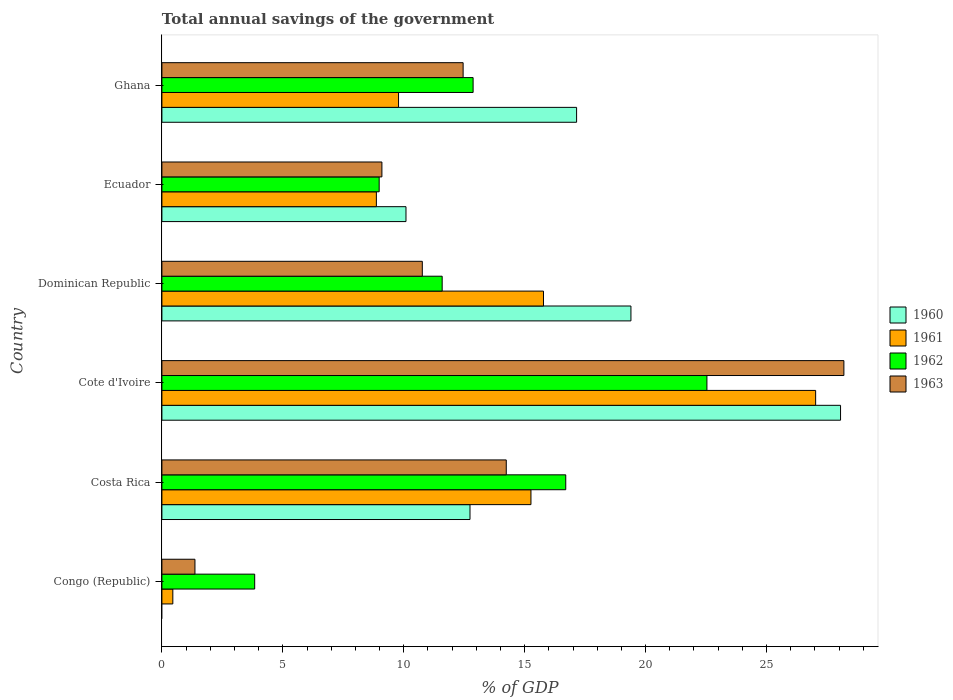How many bars are there on the 1st tick from the top?
Your response must be concise. 4. What is the label of the 4th group of bars from the top?
Your answer should be compact. Cote d'Ivoire. In how many cases, is the number of bars for a given country not equal to the number of legend labels?
Your answer should be compact. 1. What is the total annual savings of the government in 1962 in Ghana?
Give a very brief answer. 12.87. Across all countries, what is the maximum total annual savings of the government in 1962?
Make the answer very short. 22.54. In which country was the total annual savings of the government in 1960 maximum?
Give a very brief answer. Cote d'Ivoire. What is the total total annual savings of the government in 1960 in the graph?
Your response must be concise. 87.43. What is the difference between the total annual savings of the government in 1961 in Congo (Republic) and that in Ecuador?
Provide a succinct answer. -8.42. What is the difference between the total annual savings of the government in 1963 in Ghana and the total annual savings of the government in 1962 in Costa Rica?
Make the answer very short. -4.24. What is the average total annual savings of the government in 1960 per country?
Offer a very short reply. 14.57. What is the difference between the total annual savings of the government in 1963 and total annual savings of the government in 1960 in Costa Rica?
Your answer should be very brief. 1.5. In how many countries, is the total annual savings of the government in 1960 greater than 28 %?
Offer a very short reply. 1. What is the ratio of the total annual savings of the government in 1960 in Dominican Republic to that in Ghana?
Provide a succinct answer. 1.13. Is the total annual savings of the government in 1963 in Congo (Republic) less than that in Cote d'Ivoire?
Ensure brevity in your answer.  Yes. What is the difference between the highest and the second highest total annual savings of the government in 1963?
Your answer should be very brief. 13.96. What is the difference between the highest and the lowest total annual savings of the government in 1962?
Keep it short and to the point. 18.7. Is the sum of the total annual savings of the government in 1961 in Congo (Republic) and Costa Rica greater than the maximum total annual savings of the government in 1962 across all countries?
Ensure brevity in your answer.  No. Is it the case that in every country, the sum of the total annual savings of the government in 1962 and total annual savings of the government in 1960 is greater than the sum of total annual savings of the government in 1961 and total annual savings of the government in 1963?
Ensure brevity in your answer.  No. How many countries are there in the graph?
Keep it short and to the point. 6. Does the graph contain any zero values?
Your answer should be very brief. Yes. Does the graph contain grids?
Your response must be concise. No. How many legend labels are there?
Provide a succinct answer. 4. How are the legend labels stacked?
Make the answer very short. Vertical. What is the title of the graph?
Make the answer very short. Total annual savings of the government. Does "1967" appear as one of the legend labels in the graph?
Give a very brief answer. No. What is the label or title of the X-axis?
Keep it short and to the point. % of GDP. What is the label or title of the Y-axis?
Offer a terse response. Country. What is the % of GDP in 1961 in Congo (Republic)?
Your answer should be very brief. 0.45. What is the % of GDP in 1962 in Congo (Republic)?
Ensure brevity in your answer.  3.84. What is the % of GDP of 1963 in Congo (Republic)?
Your response must be concise. 1.37. What is the % of GDP of 1960 in Costa Rica?
Give a very brief answer. 12.74. What is the % of GDP in 1961 in Costa Rica?
Make the answer very short. 15.26. What is the % of GDP in 1962 in Costa Rica?
Your response must be concise. 16.7. What is the % of GDP of 1963 in Costa Rica?
Your answer should be compact. 14.24. What is the % of GDP in 1960 in Cote d'Ivoire?
Provide a succinct answer. 28.06. What is the % of GDP in 1961 in Cote d'Ivoire?
Your response must be concise. 27.03. What is the % of GDP in 1962 in Cote d'Ivoire?
Give a very brief answer. 22.54. What is the % of GDP in 1963 in Cote d'Ivoire?
Keep it short and to the point. 28.2. What is the % of GDP in 1960 in Dominican Republic?
Your answer should be compact. 19.39. What is the % of GDP in 1961 in Dominican Republic?
Make the answer very short. 15.78. What is the % of GDP in 1962 in Dominican Republic?
Keep it short and to the point. 11.59. What is the % of GDP in 1963 in Dominican Republic?
Provide a short and direct response. 10.77. What is the % of GDP of 1960 in Ecuador?
Your response must be concise. 10.09. What is the % of GDP in 1961 in Ecuador?
Your answer should be compact. 8.87. What is the % of GDP of 1962 in Ecuador?
Give a very brief answer. 8.98. What is the % of GDP in 1963 in Ecuador?
Provide a succinct answer. 9.1. What is the % of GDP in 1960 in Ghana?
Ensure brevity in your answer.  17.15. What is the % of GDP in 1961 in Ghana?
Your answer should be very brief. 9.78. What is the % of GDP in 1962 in Ghana?
Your answer should be compact. 12.87. What is the % of GDP in 1963 in Ghana?
Ensure brevity in your answer.  12.45. Across all countries, what is the maximum % of GDP in 1960?
Make the answer very short. 28.06. Across all countries, what is the maximum % of GDP of 1961?
Provide a short and direct response. 27.03. Across all countries, what is the maximum % of GDP of 1962?
Offer a terse response. 22.54. Across all countries, what is the maximum % of GDP in 1963?
Offer a very short reply. 28.2. Across all countries, what is the minimum % of GDP of 1961?
Give a very brief answer. 0.45. Across all countries, what is the minimum % of GDP of 1962?
Your answer should be compact. 3.84. Across all countries, what is the minimum % of GDP of 1963?
Your answer should be compact. 1.37. What is the total % of GDP of 1960 in the graph?
Keep it short and to the point. 87.43. What is the total % of GDP of 1961 in the graph?
Your answer should be very brief. 77.17. What is the total % of GDP in 1962 in the graph?
Provide a succinct answer. 76.51. What is the total % of GDP of 1963 in the graph?
Keep it short and to the point. 76.12. What is the difference between the % of GDP of 1961 in Congo (Republic) and that in Costa Rica?
Ensure brevity in your answer.  -14.81. What is the difference between the % of GDP of 1962 in Congo (Republic) and that in Costa Rica?
Provide a short and direct response. -12.86. What is the difference between the % of GDP in 1963 in Congo (Republic) and that in Costa Rica?
Offer a very short reply. -12.87. What is the difference between the % of GDP in 1961 in Congo (Republic) and that in Cote d'Ivoire?
Your answer should be compact. -26.58. What is the difference between the % of GDP in 1962 in Congo (Republic) and that in Cote d'Ivoire?
Keep it short and to the point. -18.7. What is the difference between the % of GDP of 1963 in Congo (Republic) and that in Cote d'Ivoire?
Your answer should be compact. -26.83. What is the difference between the % of GDP in 1961 in Congo (Republic) and that in Dominican Republic?
Ensure brevity in your answer.  -15.33. What is the difference between the % of GDP in 1962 in Congo (Republic) and that in Dominican Republic?
Ensure brevity in your answer.  -7.75. What is the difference between the % of GDP in 1963 in Congo (Republic) and that in Dominican Republic?
Your answer should be very brief. -9.4. What is the difference between the % of GDP in 1961 in Congo (Republic) and that in Ecuador?
Give a very brief answer. -8.42. What is the difference between the % of GDP in 1962 in Congo (Republic) and that in Ecuador?
Keep it short and to the point. -5.15. What is the difference between the % of GDP of 1963 in Congo (Republic) and that in Ecuador?
Give a very brief answer. -7.73. What is the difference between the % of GDP of 1961 in Congo (Republic) and that in Ghana?
Offer a very short reply. -9.33. What is the difference between the % of GDP in 1962 in Congo (Republic) and that in Ghana?
Give a very brief answer. -9.03. What is the difference between the % of GDP of 1963 in Congo (Republic) and that in Ghana?
Offer a very short reply. -11.09. What is the difference between the % of GDP in 1960 in Costa Rica and that in Cote d'Ivoire?
Provide a short and direct response. -15.32. What is the difference between the % of GDP of 1961 in Costa Rica and that in Cote d'Ivoire?
Ensure brevity in your answer.  -11.77. What is the difference between the % of GDP in 1962 in Costa Rica and that in Cote d'Ivoire?
Your response must be concise. -5.84. What is the difference between the % of GDP of 1963 in Costa Rica and that in Cote d'Ivoire?
Provide a succinct answer. -13.96. What is the difference between the % of GDP of 1960 in Costa Rica and that in Dominican Republic?
Ensure brevity in your answer.  -6.65. What is the difference between the % of GDP in 1961 in Costa Rica and that in Dominican Republic?
Keep it short and to the point. -0.52. What is the difference between the % of GDP in 1962 in Costa Rica and that in Dominican Republic?
Offer a terse response. 5.11. What is the difference between the % of GDP of 1963 in Costa Rica and that in Dominican Republic?
Offer a terse response. 3.47. What is the difference between the % of GDP of 1960 in Costa Rica and that in Ecuador?
Give a very brief answer. 2.65. What is the difference between the % of GDP of 1961 in Costa Rica and that in Ecuador?
Ensure brevity in your answer.  6.39. What is the difference between the % of GDP of 1962 in Costa Rica and that in Ecuador?
Provide a succinct answer. 7.71. What is the difference between the % of GDP in 1963 in Costa Rica and that in Ecuador?
Make the answer very short. 5.14. What is the difference between the % of GDP of 1960 in Costa Rica and that in Ghana?
Offer a very short reply. -4.41. What is the difference between the % of GDP of 1961 in Costa Rica and that in Ghana?
Provide a succinct answer. 5.47. What is the difference between the % of GDP of 1962 in Costa Rica and that in Ghana?
Offer a very short reply. 3.83. What is the difference between the % of GDP of 1963 in Costa Rica and that in Ghana?
Offer a terse response. 1.78. What is the difference between the % of GDP of 1960 in Cote d'Ivoire and that in Dominican Republic?
Give a very brief answer. 8.67. What is the difference between the % of GDP of 1961 in Cote d'Ivoire and that in Dominican Republic?
Offer a terse response. 11.25. What is the difference between the % of GDP in 1962 in Cote d'Ivoire and that in Dominican Republic?
Offer a very short reply. 10.95. What is the difference between the % of GDP in 1963 in Cote d'Ivoire and that in Dominican Republic?
Provide a short and direct response. 17.43. What is the difference between the % of GDP in 1960 in Cote d'Ivoire and that in Ecuador?
Your answer should be very brief. 17.97. What is the difference between the % of GDP of 1961 in Cote d'Ivoire and that in Ecuador?
Your response must be concise. 18.16. What is the difference between the % of GDP in 1962 in Cote d'Ivoire and that in Ecuador?
Ensure brevity in your answer.  13.55. What is the difference between the % of GDP of 1963 in Cote d'Ivoire and that in Ecuador?
Keep it short and to the point. 19.1. What is the difference between the % of GDP in 1960 in Cote d'Ivoire and that in Ghana?
Your answer should be compact. 10.91. What is the difference between the % of GDP of 1961 in Cote d'Ivoire and that in Ghana?
Give a very brief answer. 17.25. What is the difference between the % of GDP in 1962 in Cote d'Ivoire and that in Ghana?
Offer a very short reply. 9.67. What is the difference between the % of GDP in 1963 in Cote d'Ivoire and that in Ghana?
Provide a short and direct response. 15.74. What is the difference between the % of GDP in 1960 in Dominican Republic and that in Ecuador?
Your response must be concise. 9.3. What is the difference between the % of GDP of 1961 in Dominican Republic and that in Ecuador?
Your answer should be very brief. 6.91. What is the difference between the % of GDP in 1962 in Dominican Republic and that in Ecuador?
Provide a short and direct response. 2.61. What is the difference between the % of GDP in 1963 in Dominican Republic and that in Ecuador?
Provide a succinct answer. 1.67. What is the difference between the % of GDP in 1960 in Dominican Republic and that in Ghana?
Offer a terse response. 2.25. What is the difference between the % of GDP in 1961 in Dominican Republic and that in Ghana?
Give a very brief answer. 5.99. What is the difference between the % of GDP in 1962 in Dominican Republic and that in Ghana?
Ensure brevity in your answer.  -1.28. What is the difference between the % of GDP in 1963 in Dominican Republic and that in Ghana?
Offer a terse response. -1.69. What is the difference between the % of GDP in 1960 in Ecuador and that in Ghana?
Make the answer very short. -7.05. What is the difference between the % of GDP in 1961 in Ecuador and that in Ghana?
Keep it short and to the point. -0.92. What is the difference between the % of GDP in 1962 in Ecuador and that in Ghana?
Offer a terse response. -3.88. What is the difference between the % of GDP in 1963 in Ecuador and that in Ghana?
Ensure brevity in your answer.  -3.36. What is the difference between the % of GDP of 1961 in Congo (Republic) and the % of GDP of 1962 in Costa Rica?
Offer a terse response. -16.25. What is the difference between the % of GDP of 1961 in Congo (Republic) and the % of GDP of 1963 in Costa Rica?
Your response must be concise. -13.79. What is the difference between the % of GDP of 1962 in Congo (Republic) and the % of GDP of 1963 in Costa Rica?
Provide a succinct answer. -10.4. What is the difference between the % of GDP in 1961 in Congo (Republic) and the % of GDP in 1962 in Cote d'Ivoire?
Keep it short and to the point. -22.08. What is the difference between the % of GDP of 1961 in Congo (Republic) and the % of GDP of 1963 in Cote d'Ivoire?
Make the answer very short. -27.75. What is the difference between the % of GDP of 1962 in Congo (Republic) and the % of GDP of 1963 in Cote d'Ivoire?
Your answer should be very brief. -24.36. What is the difference between the % of GDP of 1961 in Congo (Republic) and the % of GDP of 1962 in Dominican Republic?
Offer a very short reply. -11.14. What is the difference between the % of GDP in 1961 in Congo (Republic) and the % of GDP in 1963 in Dominican Republic?
Your answer should be very brief. -10.32. What is the difference between the % of GDP of 1962 in Congo (Republic) and the % of GDP of 1963 in Dominican Republic?
Ensure brevity in your answer.  -6.93. What is the difference between the % of GDP of 1961 in Congo (Republic) and the % of GDP of 1962 in Ecuador?
Provide a short and direct response. -8.53. What is the difference between the % of GDP in 1961 in Congo (Republic) and the % of GDP in 1963 in Ecuador?
Make the answer very short. -8.64. What is the difference between the % of GDP of 1962 in Congo (Republic) and the % of GDP of 1963 in Ecuador?
Provide a succinct answer. -5.26. What is the difference between the % of GDP in 1961 in Congo (Republic) and the % of GDP in 1962 in Ghana?
Provide a succinct answer. -12.42. What is the difference between the % of GDP of 1961 in Congo (Republic) and the % of GDP of 1963 in Ghana?
Your answer should be very brief. -12. What is the difference between the % of GDP in 1962 in Congo (Republic) and the % of GDP in 1963 in Ghana?
Provide a succinct answer. -8.62. What is the difference between the % of GDP of 1960 in Costa Rica and the % of GDP of 1961 in Cote d'Ivoire?
Provide a succinct answer. -14.29. What is the difference between the % of GDP of 1960 in Costa Rica and the % of GDP of 1962 in Cote d'Ivoire?
Your response must be concise. -9.8. What is the difference between the % of GDP of 1960 in Costa Rica and the % of GDP of 1963 in Cote d'Ivoire?
Offer a terse response. -15.46. What is the difference between the % of GDP of 1961 in Costa Rica and the % of GDP of 1962 in Cote d'Ivoire?
Your answer should be compact. -7.28. What is the difference between the % of GDP in 1961 in Costa Rica and the % of GDP in 1963 in Cote d'Ivoire?
Offer a terse response. -12.94. What is the difference between the % of GDP in 1962 in Costa Rica and the % of GDP in 1963 in Cote d'Ivoire?
Your response must be concise. -11.5. What is the difference between the % of GDP of 1960 in Costa Rica and the % of GDP of 1961 in Dominican Republic?
Your answer should be compact. -3.04. What is the difference between the % of GDP in 1960 in Costa Rica and the % of GDP in 1962 in Dominican Republic?
Offer a terse response. 1.15. What is the difference between the % of GDP in 1960 in Costa Rica and the % of GDP in 1963 in Dominican Republic?
Ensure brevity in your answer.  1.97. What is the difference between the % of GDP of 1961 in Costa Rica and the % of GDP of 1962 in Dominican Republic?
Keep it short and to the point. 3.67. What is the difference between the % of GDP of 1961 in Costa Rica and the % of GDP of 1963 in Dominican Republic?
Offer a terse response. 4.49. What is the difference between the % of GDP in 1962 in Costa Rica and the % of GDP in 1963 in Dominican Republic?
Your answer should be compact. 5.93. What is the difference between the % of GDP of 1960 in Costa Rica and the % of GDP of 1961 in Ecuador?
Your answer should be very brief. 3.87. What is the difference between the % of GDP in 1960 in Costa Rica and the % of GDP in 1962 in Ecuador?
Keep it short and to the point. 3.76. What is the difference between the % of GDP in 1960 in Costa Rica and the % of GDP in 1963 in Ecuador?
Offer a terse response. 3.64. What is the difference between the % of GDP of 1961 in Costa Rica and the % of GDP of 1962 in Ecuador?
Your answer should be very brief. 6.28. What is the difference between the % of GDP in 1961 in Costa Rica and the % of GDP in 1963 in Ecuador?
Make the answer very short. 6.16. What is the difference between the % of GDP in 1962 in Costa Rica and the % of GDP in 1963 in Ecuador?
Your response must be concise. 7.6. What is the difference between the % of GDP of 1960 in Costa Rica and the % of GDP of 1961 in Ghana?
Your answer should be very brief. 2.95. What is the difference between the % of GDP of 1960 in Costa Rica and the % of GDP of 1962 in Ghana?
Offer a terse response. -0.13. What is the difference between the % of GDP of 1960 in Costa Rica and the % of GDP of 1963 in Ghana?
Provide a short and direct response. 0.28. What is the difference between the % of GDP in 1961 in Costa Rica and the % of GDP in 1962 in Ghana?
Provide a short and direct response. 2.39. What is the difference between the % of GDP of 1961 in Costa Rica and the % of GDP of 1963 in Ghana?
Your response must be concise. 2.81. What is the difference between the % of GDP of 1962 in Costa Rica and the % of GDP of 1963 in Ghana?
Provide a succinct answer. 4.24. What is the difference between the % of GDP in 1960 in Cote d'Ivoire and the % of GDP in 1961 in Dominican Republic?
Ensure brevity in your answer.  12.28. What is the difference between the % of GDP in 1960 in Cote d'Ivoire and the % of GDP in 1962 in Dominican Republic?
Provide a succinct answer. 16.47. What is the difference between the % of GDP of 1960 in Cote d'Ivoire and the % of GDP of 1963 in Dominican Republic?
Provide a short and direct response. 17.29. What is the difference between the % of GDP of 1961 in Cote d'Ivoire and the % of GDP of 1962 in Dominican Republic?
Provide a short and direct response. 15.44. What is the difference between the % of GDP in 1961 in Cote d'Ivoire and the % of GDP in 1963 in Dominican Republic?
Keep it short and to the point. 16.26. What is the difference between the % of GDP of 1962 in Cote d'Ivoire and the % of GDP of 1963 in Dominican Republic?
Ensure brevity in your answer.  11.77. What is the difference between the % of GDP in 1960 in Cote d'Ivoire and the % of GDP in 1961 in Ecuador?
Keep it short and to the point. 19.19. What is the difference between the % of GDP in 1960 in Cote d'Ivoire and the % of GDP in 1962 in Ecuador?
Your response must be concise. 19.08. What is the difference between the % of GDP of 1960 in Cote d'Ivoire and the % of GDP of 1963 in Ecuador?
Your response must be concise. 18.96. What is the difference between the % of GDP of 1961 in Cote d'Ivoire and the % of GDP of 1962 in Ecuador?
Ensure brevity in your answer.  18.05. What is the difference between the % of GDP in 1961 in Cote d'Ivoire and the % of GDP in 1963 in Ecuador?
Make the answer very short. 17.93. What is the difference between the % of GDP of 1962 in Cote d'Ivoire and the % of GDP of 1963 in Ecuador?
Offer a terse response. 13.44. What is the difference between the % of GDP of 1960 in Cote d'Ivoire and the % of GDP of 1961 in Ghana?
Give a very brief answer. 18.27. What is the difference between the % of GDP in 1960 in Cote d'Ivoire and the % of GDP in 1962 in Ghana?
Ensure brevity in your answer.  15.19. What is the difference between the % of GDP in 1960 in Cote d'Ivoire and the % of GDP in 1963 in Ghana?
Keep it short and to the point. 15.61. What is the difference between the % of GDP in 1961 in Cote d'Ivoire and the % of GDP in 1962 in Ghana?
Provide a short and direct response. 14.16. What is the difference between the % of GDP of 1961 in Cote d'Ivoire and the % of GDP of 1963 in Ghana?
Offer a terse response. 14.58. What is the difference between the % of GDP in 1962 in Cote d'Ivoire and the % of GDP in 1963 in Ghana?
Keep it short and to the point. 10.08. What is the difference between the % of GDP of 1960 in Dominican Republic and the % of GDP of 1961 in Ecuador?
Provide a short and direct response. 10.53. What is the difference between the % of GDP in 1960 in Dominican Republic and the % of GDP in 1962 in Ecuador?
Give a very brief answer. 10.41. What is the difference between the % of GDP in 1960 in Dominican Republic and the % of GDP in 1963 in Ecuador?
Your response must be concise. 10.3. What is the difference between the % of GDP in 1961 in Dominican Republic and the % of GDP in 1962 in Ecuador?
Your answer should be compact. 6.79. What is the difference between the % of GDP in 1961 in Dominican Republic and the % of GDP in 1963 in Ecuador?
Offer a terse response. 6.68. What is the difference between the % of GDP in 1962 in Dominican Republic and the % of GDP in 1963 in Ecuador?
Ensure brevity in your answer.  2.49. What is the difference between the % of GDP of 1960 in Dominican Republic and the % of GDP of 1961 in Ghana?
Offer a terse response. 9.61. What is the difference between the % of GDP in 1960 in Dominican Republic and the % of GDP in 1962 in Ghana?
Offer a terse response. 6.53. What is the difference between the % of GDP of 1960 in Dominican Republic and the % of GDP of 1963 in Ghana?
Provide a short and direct response. 6.94. What is the difference between the % of GDP of 1961 in Dominican Republic and the % of GDP of 1962 in Ghana?
Give a very brief answer. 2.91. What is the difference between the % of GDP in 1961 in Dominican Republic and the % of GDP in 1963 in Ghana?
Give a very brief answer. 3.32. What is the difference between the % of GDP of 1962 in Dominican Republic and the % of GDP of 1963 in Ghana?
Make the answer very short. -0.87. What is the difference between the % of GDP of 1960 in Ecuador and the % of GDP of 1961 in Ghana?
Ensure brevity in your answer.  0.31. What is the difference between the % of GDP in 1960 in Ecuador and the % of GDP in 1962 in Ghana?
Offer a very short reply. -2.77. What is the difference between the % of GDP of 1960 in Ecuador and the % of GDP of 1963 in Ghana?
Give a very brief answer. -2.36. What is the difference between the % of GDP of 1961 in Ecuador and the % of GDP of 1962 in Ghana?
Give a very brief answer. -4. What is the difference between the % of GDP in 1961 in Ecuador and the % of GDP in 1963 in Ghana?
Provide a succinct answer. -3.59. What is the difference between the % of GDP in 1962 in Ecuador and the % of GDP in 1963 in Ghana?
Offer a very short reply. -3.47. What is the average % of GDP of 1960 per country?
Give a very brief answer. 14.57. What is the average % of GDP of 1961 per country?
Offer a very short reply. 12.86. What is the average % of GDP in 1962 per country?
Give a very brief answer. 12.75. What is the average % of GDP of 1963 per country?
Your response must be concise. 12.69. What is the difference between the % of GDP in 1961 and % of GDP in 1962 in Congo (Republic)?
Provide a succinct answer. -3.38. What is the difference between the % of GDP in 1961 and % of GDP in 1963 in Congo (Republic)?
Offer a terse response. -0.91. What is the difference between the % of GDP of 1962 and % of GDP of 1963 in Congo (Republic)?
Provide a succinct answer. 2.47. What is the difference between the % of GDP in 1960 and % of GDP in 1961 in Costa Rica?
Ensure brevity in your answer.  -2.52. What is the difference between the % of GDP in 1960 and % of GDP in 1962 in Costa Rica?
Provide a succinct answer. -3.96. What is the difference between the % of GDP of 1960 and % of GDP of 1963 in Costa Rica?
Your answer should be very brief. -1.5. What is the difference between the % of GDP of 1961 and % of GDP of 1962 in Costa Rica?
Your response must be concise. -1.44. What is the difference between the % of GDP in 1961 and % of GDP in 1963 in Costa Rica?
Make the answer very short. 1.02. What is the difference between the % of GDP in 1962 and % of GDP in 1963 in Costa Rica?
Your answer should be very brief. 2.46. What is the difference between the % of GDP of 1960 and % of GDP of 1961 in Cote d'Ivoire?
Make the answer very short. 1.03. What is the difference between the % of GDP in 1960 and % of GDP in 1962 in Cote d'Ivoire?
Make the answer very short. 5.52. What is the difference between the % of GDP of 1960 and % of GDP of 1963 in Cote d'Ivoire?
Offer a terse response. -0.14. What is the difference between the % of GDP of 1961 and % of GDP of 1962 in Cote d'Ivoire?
Your response must be concise. 4.49. What is the difference between the % of GDP in 1961 and % of GDP in 1963 in Cote d'Ivoire?
Keep it short and to the point. -1.17. What is the difference between the % of GDP of 1962 and % of GDP of 1963 in Cote d'Ivoire?
Make the answer very short. -5.66. What is the difference between the % of GDP of 1960 and % of GDP of 1961 in Dominican Republic?
Keep it short and to the point. 3.62. What is the difference between the % of GDP of 1960 and % of GDP of 1962 in Dominican Republic?
Provide a short and direct response. 7.8. What is the difference between the % of GDP in 1960 and % of GDP in 1963 in Dominican Republic?
Provide a short and direct response. 8.63. What is the difference between the % of GDP of 1961 and % of GDP of 1962 in Dominican Republic?
Your answer should be very brief. 4.19. What is the difference between the % of GDP of 1961 and % of GDP of 1963 in Dominican Republic?
Give a very brief answer. 5.01. What is the difference between the % of GDP in 1962 and % of GDP in 1963 in Dominican Republic?
Provide a succinct answer. 0.82. What is the difference between the % of GDP of 1960 and % of GDP of 1961 in Ecuador?
Your answer should be very brief. 1.22. What is the difference between the % of GDP of 1960 and % of GDP of 1962 in Ecuador?
Offer a very short reply. 1.11. What is the difference between the % of GDP of 1960 and % of GDP of 1963 in Ecuador?
Ensure brevity in your answer.  1. What is the difference between the % of GDP of 1961 and % of GDP of 1962 in Ecuador?
Offer a very short reply. -0.12. What is the difference between the % of GDP in 1961 and % of GDP in 1963 in Ecuador?
Give a very brief answer. -0.23. What is the difference between the % of GDP of 1962 and % of GDP of 1963 in Ecuador?
Ensure brevity in your answer.  -0.11. What is the difference between the % of GDP in 1960 and % of GDP in 1961 in Ghana?
Your answer should be compact. 7.36. What is the difference between the % of GDP of 1960 and % of GDP of 1962 in Ghana?
Provide a succinct answer. 4.28. What is the difference between the % of GDP in 1960 and % of GDP in 1963 in Ghana?
Offer a terse response. 4.69. What is the difference between the % of GDP of 1961 and % of GDP of 1962 in Ghana?
Provide a succinct answer. -3.08. What is the difference between the % of GDP in 1961 and % of GDP in 1963 in Ghana?
Ensure brevity in your answer.  -2.67. What is the difference between the % of GDP in 1962 and % of GDP in 1963 in Ghana?
Ensure brevity in your answer.  0.41. What is the ratio of the % of GDP of 1961 in Congo (Republic) to that in Costa Rica?
Provide a succinct answer. 0.03. What is the ratio of the % of GDP of 1962 in Congo (Republic) to that in Costa Rica?
Give a very brief answer. 0.23. What is the ratio of the % of GDP in 1963 in Congo (Republic) to that in Costa Rica?
Your response must be concise. 0.1. What is the ratio of the % of GDP of 1961 in Congo (Republic) to that in Cote d'Ivoire?
Provide a succinct answer. 0.02. What is the ratio of the % of GDP in 1962 in Congo (Republic) to that in Cote d'Ivoire?
Your answer should be very brief. 0.17. What is the ratio of the % of GDP of 1963 in Congo (Republic) to that in Cote d'Ivoire?
Ensure brevity in your answer.  0.05. What is the ratio of the % of GDP in 1961 in Congo (Republic) to that in Dominican Republic?
Your answer should be compact. 0.03. What is the ratio of the % of GDP of 1962 in Congo (Republic) to that in Dominican Republic?
Provide a succinct answer. 0.33. What is the ratio of the % of GDP of 1963 in Congo (Republic) to that in Dominican Republic?
Provide a succinct answer. 0.13. What is the ratio of the % of GDP in 1961 in Congo (Republic) to that in Ecuador?
Your response must be concise. 0.05. What is the ratio of the % of GDP in 1962 in Congo (Republic) to that in Ecuador?
Give a very brief answer. 0.43. What is the ratio of the % of GDP in 1963 in Congo (Republic) to that in Ecuador?
Give a very brief answer. 0.15. What is the ratio of the % of GDP in 1961 in Congo (Republic) to that in Ghana?
Make the answer very short. 0.05. What is the ratio of the % of GDP in 1962 in Congo (Republic) to that in Ghana?
Keep it short and to the point. 0.3. What is the ratio of the % of GDP of 1963 in Congo (Republic) to that in Ghana?
Offer a terse response. 0.11. What is the ratio of the % of GDP of 1960 in Costa Rica to that in Cote d'Ivoire?
Keep it short and to the point. 0.45. What is the ratio of the % of GDP of 1961 in Costa Rica to that in Cote d'Ivoire?
Ensure brevity in your answer.  0.56. What is the ratio of the % of GDP of 1962 in Costa Rica to that in Cote d'Ivoire?
Give a very brief answer. 0.74. What is the ratio of the % of GDP of 1963 in Costa Rica to that in Cote d'Ivoire?
Provide a short and direct response. 0.5. What is the ratio of the % of GDP in 1960 in Costa Rica to that in Dominican Republic?
Offer a terse response. 0.66. What is the ratio of the % of GDP in 1961 in Costa Rica to that in Dominican Republic?
Your answer should be very brief. 0.97. What is the ratio of the % of GDP in 1962 in Costa Rica to that in Dominican Republic?
Your answer should be compact. 1.44. What is the ratio of the % of GDP in 1963 in Costa Rica to that in Dominican Republic?
Offer a terse response. 1.32. What is the ratio of the % of GDP of 1960 in Costa Rica to that in Ecuador?
Your response must be concise. 1.26. What is the ratio of the % of GDP of 1961 in Costa Rica to that in Ecuador?
Your answer should be very brief. 1.72. What is the ratio of the % of GDP in 1962 in Costa Rica to that in Ecuador?
Offer a terse response. 1.86. What is the ratio of the % of GDP of 1963 in Costa Rica to that in Ecuador?
Ensure brevity in your answer.  1.57. What is the ratio of the % of GDP of 1960 in Costa Rica to that in Ghana?
Ensure brevity in your answer.  0.74. What is the ratio of the % of GDP of 1961 in Costa Rica to that in Ghana?
Offer a terse response. 1.56. What is the ratio of the % of GDP in 1962 in Costa Rica to that in Ghana?
Ensure brevity in your answer.  1.3. What is the ratio of the % of GDP in 1963 in Costa Rica to that in Ghana?
Provide a short and direct response. 1.14. What is the ratio of the % of GDP in 1960 in Cote d'Ivoire to that in Dominican Republic?
Offer a terse response. 1.45. What is the ratio of the % of GDP in 1961 in Cote d'Ivoire to that in Dominican Republic?
Make the answer very short. 1.71. What is the ratio of the % of GDP of 1962 in Cote d'Ivoire to that in Dominican Republic?
Provide a succinct answer. 1.94. What is the ratio of the % of GDP of 1963 in Cote d'Ivoire to that in Dominican Republic?
Provide a succinct answer. 2.62. What is the ratio of the % of GDP in 1960 in Cote d'Ivoire to that in Ecuador?
Offer a very short reply. 2.78. What is the ratio of the % of GDP in 1961 in Cote d'Ivoire to that in Ecuador?
Your response must be concise. 3.05. What is the ratio of the % of GDP of 1962 in Cote d'Ivoire to that in Ecuador?
Offer a very short reply. 2.51. What is the ratio of the % of GDP of 1963 in Cote d'Ivoire to that in Ecuador?
Your answer should be compact. 3.1. What is the ratio of the % of GDP in 1960 in Cote d'Ivoire to that in Ghana?
Offer a very short reply. 1.64. What is the ratio of the % of GDP in 1961 in Cote d'Ivoire to that in Ghana?
Your answer should be compact. 2.76. What is the ratio of the % of GDP in 1962 in Cote d'Ivoire to that in Ghana?
Your answer should be compact. 1.75. What is the ratio of the % of GDP of 1963 in Cote d'Ivoire to that in Ghana?
Make the answer very short. 2.26. What is the ratio of the % of GDP in 1960 in Dominican Republic to that in Ecuador?
Offer a terse response. 1.92. What is the ratio of the % of GDP of 1961 in Dominican Republic to that in Ecuador?
Ensure brevity in your answer.  1.78. What is the ratio of the % of GDP of 1962 in Dominican Republic to that in Ecuador?
Give a very brief answer. 1.29. What is the ratio of the % of GDP in 1963 in Dominican Republic to that in Ecuador?
Provide a short and direct response. 1.18. What is the ratio of the % of GDP of 1960 in Dominican Republic to that in Ghana?
Your answer should be very brief. 1.13. What is the ratio of the % of GDP of 1961 in Dominican Republic to that in Ghana?
Make the answer very short. 1.61. What is the ratio of the % of GDP in 1962 in Dominican Republic to that in Ghana?
Offer a very short reply. 0.9. What is the ratio of the % of GDP in 1963 in Dominican Republic to that in Ghana?
Your answer should be very brief. 0.86. What is the ratio of the % of GDP in 1960 in Ecuador to that in Ghana?
Your answer should be compact. 0.59. What is the ratio of the % of GDP of 1961 in Ecuador to that in Ghana?
Give a very brief answer. 0.91. What is the ratio of the % of GDP of 1962 in Ecuador to that in Ghana?
Your answer should be compact. 0.7. What is the ratio of the % of GDP of 1963 in Ecuador to that in Ghana?
Ensure brevity in your answer.  0.73. What is the difference between the highest and the second highest % of GDP in 1960?
Give a very brief answer. 8.67. What is the difference between the highest and the second highest % of GDP of 1961?
Make the answer very short. 11.25. What is the difference between the highest and the second highest % of GDP of 1962?
Your answer should be very brief. 5.84. What is the difference between the highest and the second highest % of GDP of 1963?
Make the answer very short. 13.96. What is the difference between the highest and the lowest % of GDP in 1960?
Make the answer very short. 28.06. What is the difference between the highest and the lowest % of GDP in 1961?
Give a very brief answer. 26.58. What is the difference between the highest and the lowest % of GDP in 1962?
Make the answer very short. 18.7. What is the difference between the highest and the lowest % of GDP in 1963?
Ensure brevity in your answer.  26.83. 